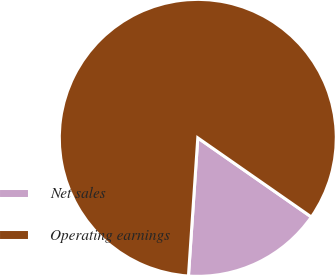Convert chart to OTSL. <chart><loc_0><loc_0><loc_500><loc_500><pie_chart><fcel>Net sales<fcel>Operating earnings<nl><fcel>16.39%<fcel>83.61%<nl></chart> 